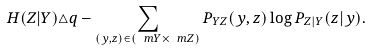<formula> <loc_0><loc_0><loc_500><loc_500>H ( Z | Y ) \triangle q - \sum _ { ( y , z ) \in ( \ m { Y } \times \ m { Z } ) } P _ { Y Z } ( y , z ) \log P _ { Z | Y } ( z | y ) .</formula> 